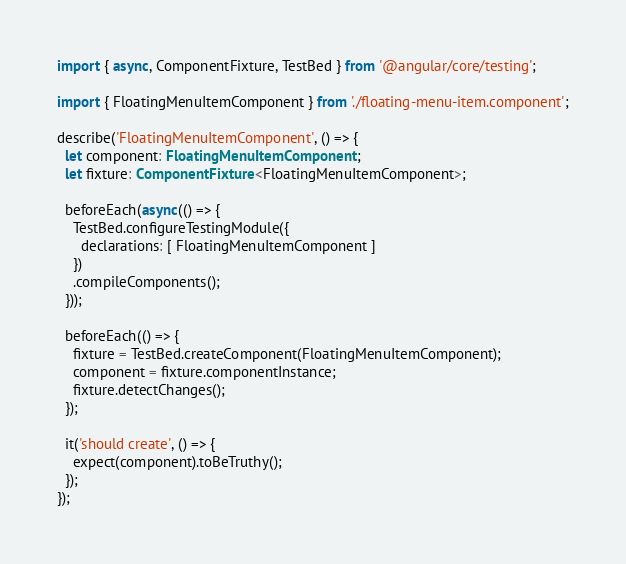<code> <loc_0><loc_0><loc_500><loc_500><_TypeScript_>import { async, ComponentFixture, TestBed } from '@angular/core/testing';

import { FloatingMenuItemComponent } from './floating-menu-item.component';

describe('FloatingMenuItemComponent', () => {
  let component: FloatingMenuItemComponent;
  let fixture: ComponentFixture<FloatingMenuItemComponent>;

  beforeEach(async(() => {
    TestBed.configureTestingModule({
      declarations: [ FloatingMenuItemComponent ]
    })
    .compileComponents();
  }));

  beforeEach(() => {
    fixture = TestBed.createComponent(FloatingMenuItemComponent);
    component = fixture.componentInstance;
    fixture.detectChanges();
  });

  it('should create', () => {
    expect(component).toBeTruthy();
  });
});
</code> 